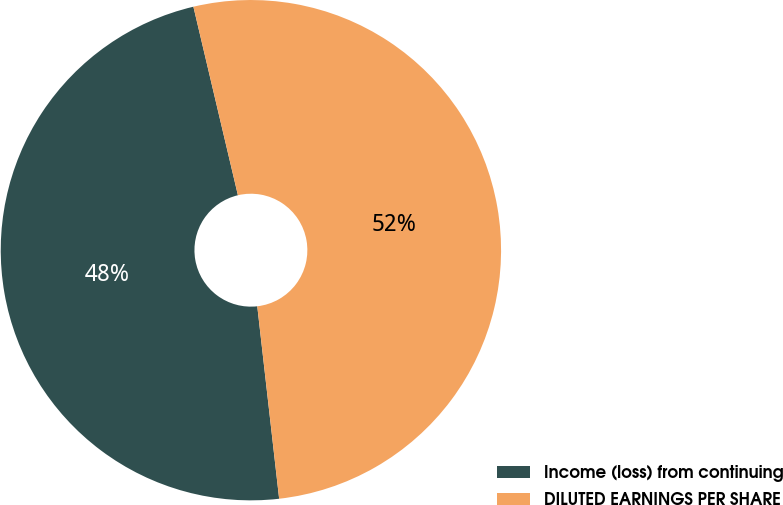Convert chart to OTSL. <chart><loc_0><loc_0><loc_500><loc_500><pie_chart><fcel>Income (loss) from continuing<fcel>DILUTED EARNINGS PER SHARE<nl><fcel>48.11%<fcel>51.89%<nl></chart> 